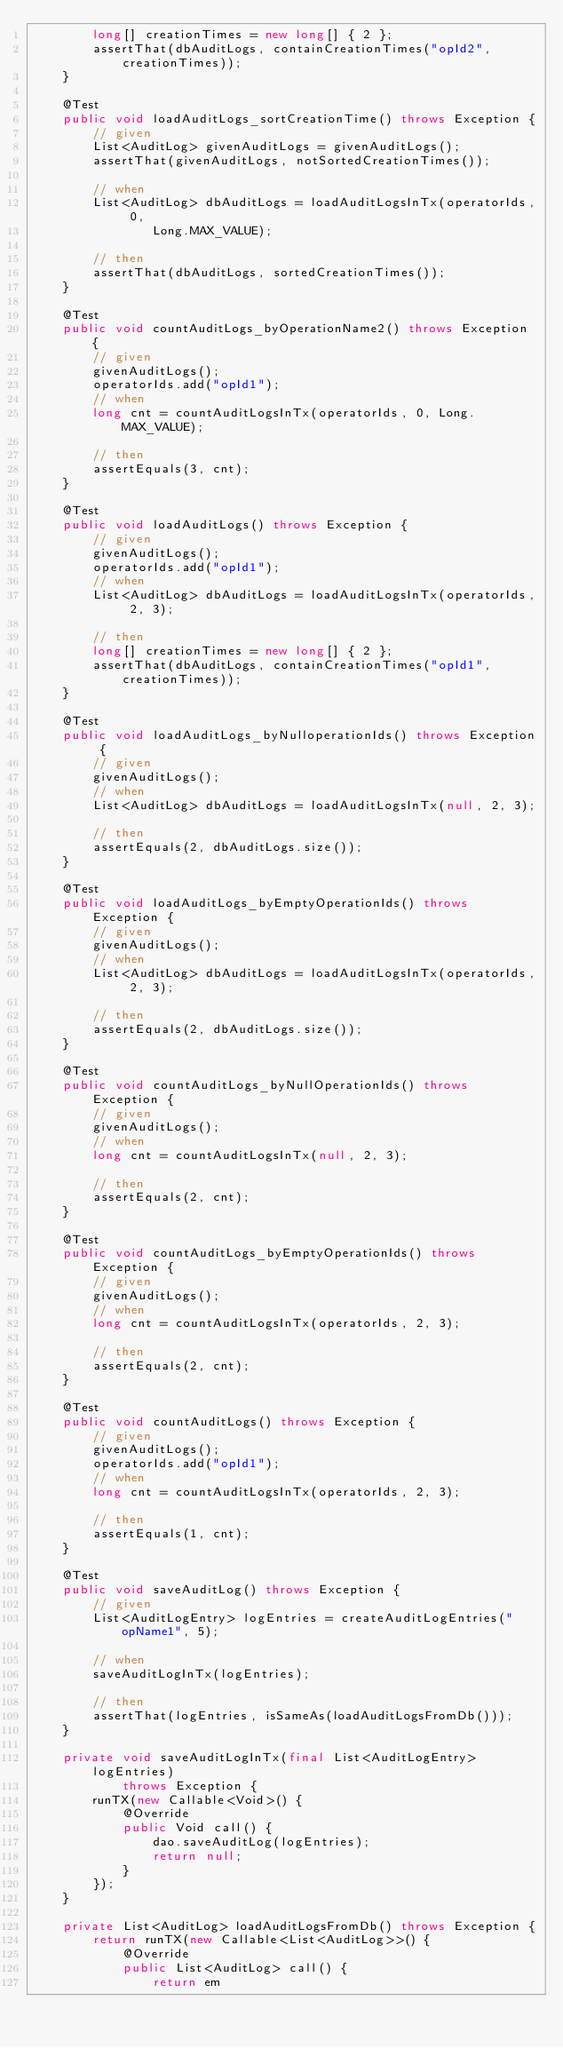<code> <loc_0><loc_0><loc_500><loc_500><_Java_>        long[] creationTimes = new long[] { 2 };
        assertThat(dbAuditLogs, containCreationTimes("opId2", creationTimes));
    }

    @Test
    public void loadAuditLogs_sortCreationTime() throws Exception {
        // given
        List<AuditLog> givenAuditLogs = givenAuditLogs();
        assertThat(givenAuditLogs, notSortedCreationTimes());

        // when
        List<AuditLog> dbAuditLogs = loadAuditLogsInTx(operatorIds, 0,
                Long.MAX_VALUE);

        // then
        assertThat(dbAuditLogs, sortedCreationTimes());
    }

    @Test
    public void countAuditLogs_byOperationName2() throws Exception {
        // given
        givenAuditLogs();
        operatorIds.add("opId1");
        // when
        long cnt = countAuditLogsInTx(operatorIds, 0, Long.MAX_VALUE);

        // then
        assertEquals(3, cnt);
    }

    @Test
    public void loadAuditLogs() throws Exception {
        // given
        givenAuditLogs();
        operatorIds.add("opId1");
        // when
        List<AuditLog> dbAuditLogs = loadAuditLogsInTx(operatorIds, 2, 3);

        // then
        long[] creationTimes = new long[] { 2 };
        assertThat(dbAuditLogs, containCreationTimes("opId1", creationTimes));
    }

    @Test
    public void loadAuditLogs_byNulloperationIds() throws Exception {
        // given
        givenAuditLogs();
        // when
        List<AuditLog> dbAuditLogs = loadAuditLogsInTx(null, 2, 3);

        // then
        assertEquals(2, dbAuditLogs.size());
    }

    @Test
    public void loadAuditLogs_byEmptyOperationIds() throws Exception {
        // given
        givenAuditLogs();
        // when
        List<AuditLog> dbAuditLogs = loadAuditLogsInTx(operatorIds, 2, 3);

        // then
        assertEquals(2, dbAuditLogs.size());
    }

    @Test
    public void countAuditLogs_byNullOperationIds() throws Exception {
        // given
        givenAuditLogs();
        // when
        long cnt = countAuditLogsInTx(null, 2, 3);

        // then
        assertEquals(2, cnt);
    }

    @Test
    public void countAuditLogs_byEmptyOperationIds() throws Exception {
        // given
        givenAuditLogs();
        // when
        long cnt = countAuditLogsInTx(operatorIds, 2, 3);

        // then
        assertEquals(2, cnt);
    }

    @Test
    public void countAuditLogs() throws Exception {
        // given
        givenAuditLogs();
        operatorIds.add("opId1");
        // when
        long cnt = countAuditLogsInTx(operatorIds, 2, 3);

        // then
        assertEquals(1, cnt);
    }

    @Test
    public void saveAuditLog() throws Exception {
        // given
        List<AuditLogEntry> logEntries = createAuditLogEntries("opName1", 5);

        // when
        saveAuditLogInTx(logEntries);

        // then
        assertThat(logEntries, isSameAs(loadAuditLogsFromDb()));
    }

    private void saveAuditLogInTx(final List<AuditLogEntry> logEntries)
            throws Exception {
        runTX(new Callable<Void>() {
            @Override
            public Void call() {
                dao.saveAuditLog(logEntries);
                return null;
            }
        });
    }

    private List<AuditLog> loadAuditLogsFromDb() throws Exception {
        return runTX(new Callable<List<AuditLog>>() {
            @Override
            public List<AuditLog> call() {
                return em</code> 